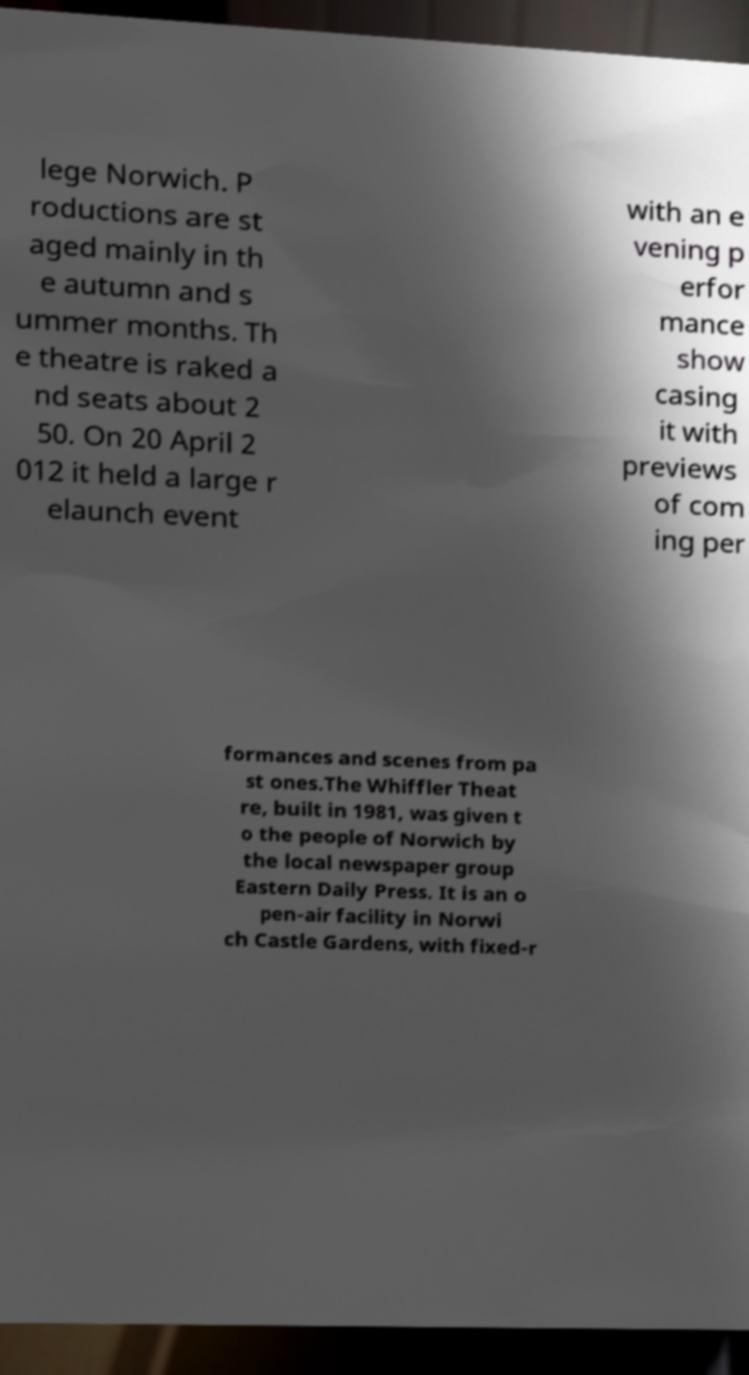Please identify and transcribe the text found in this image. lege Norwich. P roductions are st aged mainly in th e autumn and s ummer months. Th e theatre is raked a nd seats about 2 50. On 20 April 2 012 it held a large r elaunch event with an e vening p erfor mance show casing it with previews of com ing per formances and scenes from pa st ones.The Whiffler Theat re, built in 1981, was given t o the people of Norwich by the local newspaper group Eastern Daily Press. It is an o pen-air facility in Norwi ch Castle Gardens, with fixed-r 